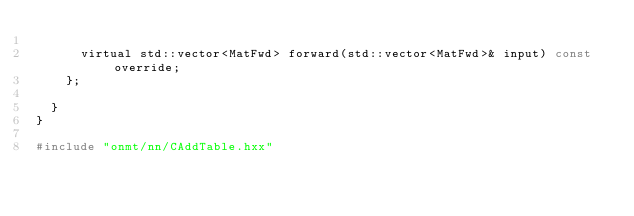Convert code to text. <code><loc_0><loc_0><loc_500><loc_500><_C_>
      virtual std::vector<MatFwd> forward(std::vector<MatFwd>& input) const override;
    };

  }
}

#include "onmt/nn/CAddTable.hxx"
</code> 